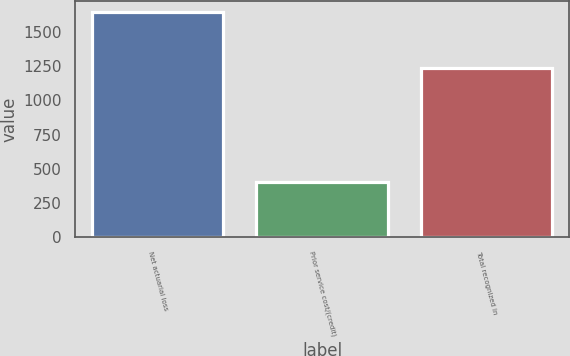Convert chart to OTSL. <chart><loc_0><loc_0><loc_500><loc_500><bar_chart><fcel>Net actuarial loss<fcel>Prior service cost/(credit)<fcel>Total recognized in<nl><fcel>1644<fcel>403<fcel>1241<nl></chart> 